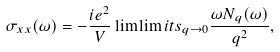Convert formula to latex. <formula><loc_0><loc_0><loc_500><loc_500>\sigma _ { x x } ( \omega ) = - \frac { i e ^ { 2 } } { V } \lim \lim i t s _ { q \to 0 } \frac { \omega N _ { q } ( \omega ) } { q ^ { 2 } } ,</formula> 